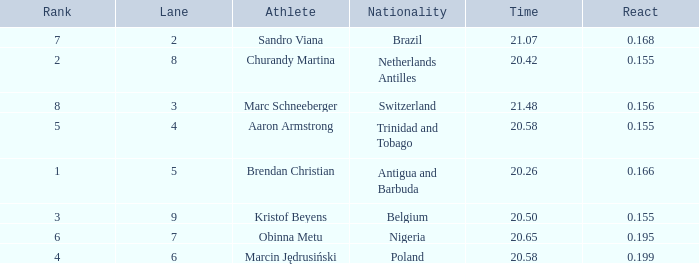How much Time has a Reaction of 0.155, and an Athlete of kristof beyens, and a Rank smaller than 3? 0.0. Write the full table. {'header': ['Rank', 'Lane', 'Athlete', 'Nationality', 'Time', 'React'], 'rows': [['7', '2', 'Sandro Viana', 'Brazil', '21.07', '0.168'], ['2', '8', 'Churandy Martina', 'Netherlands Antilles', '20.42', '0.155'], ['8', '3', 'Marc Schneeberger', 'Switzerland', '21.48', '0.156'], ['5', '4', 'Aaron Armstrong', 'Trinidad and Tobago', '20.58', '0.155'], ['1', '5', 'Brendan Christian', 'Antigua and Barbuda', '20.26', '0.166'], ['3', '9', 'Kristof Beyens', 'Belgium', '20.50', '0.155'], ['6', '7', 'Obinna Metu', 'Nigeria', '20.65', '0.195'], ['4', '6', 'Marcin Jędrusiński', 'Poland', '20.58', '0.199']]} 